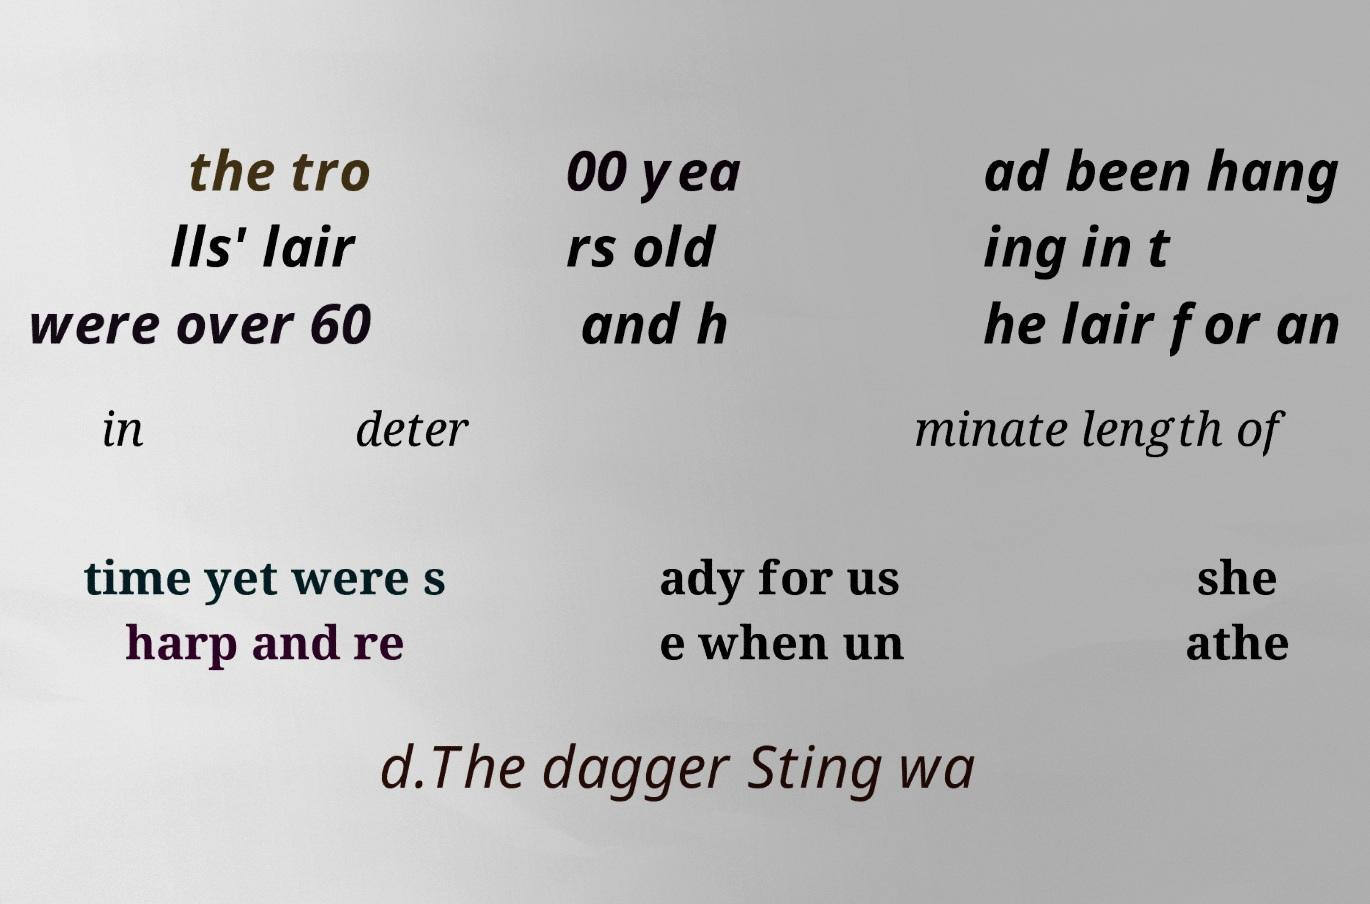There's text embedded in this image that I need extracted. Can you transcribe it verbatim? the tro lls' lair were over 60 00 yea rs old and h ad been hang ing in t he lair for an in deter minate length of time yet were s harp and re ady for us e when un she athe d.The dagger Sting wa 